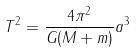Convert formula to latex. <formula><loc_0><loc_0><loc_500><loc_500>T ^ { 2 } = \frac { 4 \pi ^ { 2 } } { G ( M + m ) } a ^ { 3 }</formula> 